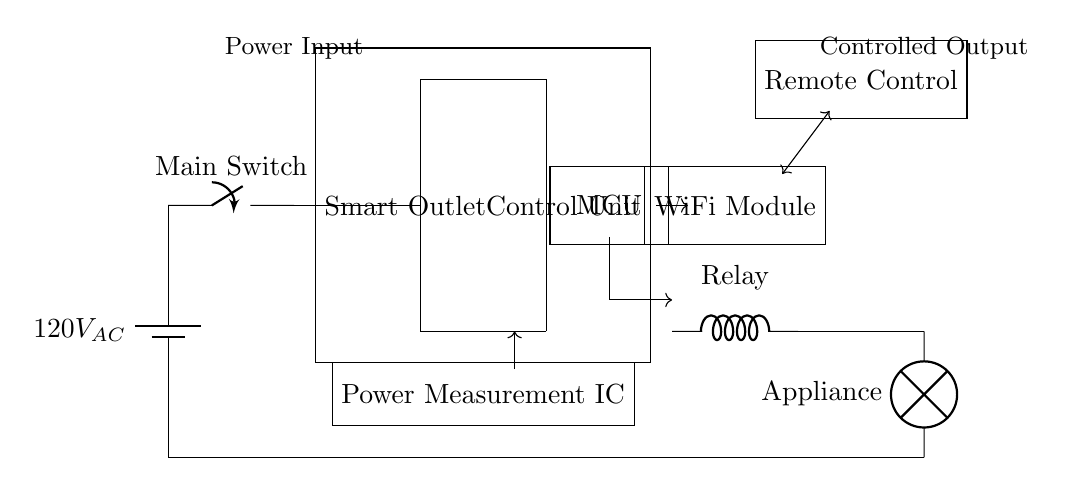What is the main voltage of this circuit? The main voltage is indicated as 120V AC, which is labeled next to the battery symbol representing the power source.
Answer: 120V AC What component measures power in this circuit? The Power Measurement IC is responsible for measuring power. It is labeled in the circuit diagram and is positioned beneath the Smart Outlet Control Unit.
Answer: Power Measurement IC How does the remote control connect to the circuit? The remote control connects to the relay via control signals, indicated by the arrow lines showing the connection from the WiFi module to the relay. This indicates that the signal travels from the remote control through the WiFi module to activate the relay.
Answer: Relay Which component is used for wireless communication? The WiFi Module is the component responsible for wireless communication. It is depicted in the circuit diagram as a separate unit connected to the microcontroller and the relay.
Answer: WiFi Module What is the purpose of the relay in this circuit? The relay serves to control the on/off state of the appliance based on the control signals received from the microcontroller, thus enabling or disabling power to the appliance. This function is essential for remote control capabilities.
Answer: Control power How many main components are in the smart outlet control unit? The Smart Outlet Control Unit contains three main components: the Microcontroller (MCU), the WiFi Module, and the Power Measurement IC. Together, they facilitate the smart functionality of the outlet.
Answer: Three What is the output load device in this circuit? The output load device represented in the circuit is the Appliance, which is shown connected to the output of the smart outlet circuit. This indicates that it receives power from the smart outlet.
Answer: Appliance 